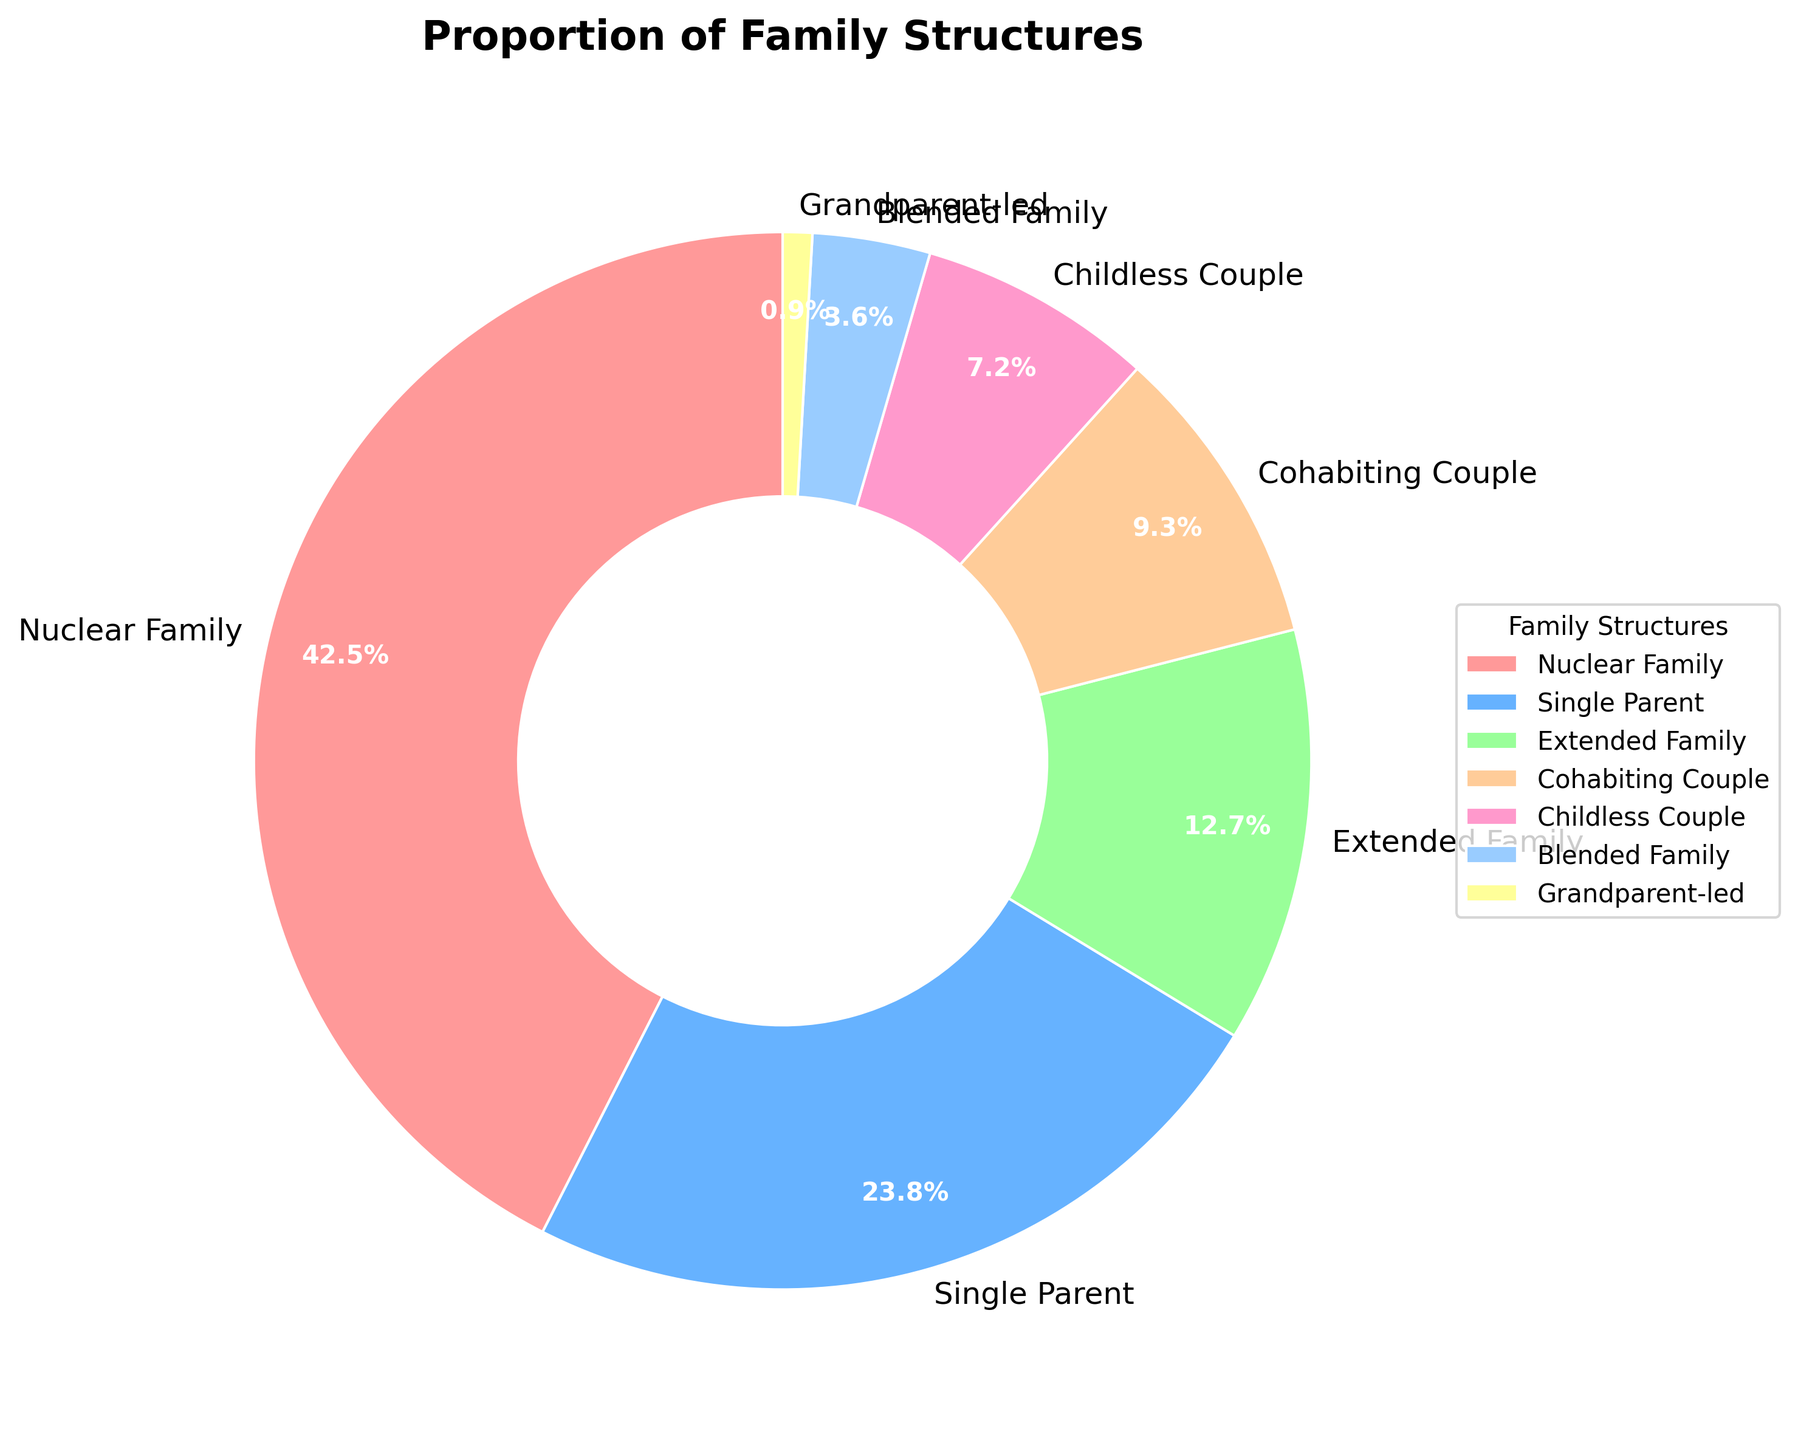What is the most common family structure in the population? To determine this, we look at the pie chart and identify the family structure with the largest slice. The provided data shows that "Nuclear Family" has the highest percentage at 42.5%.
Answer: Nuclear Family Which family structure has the smallest proportion in the population? By inspecting the pie chart, we identify the smallest slice, which corresponds to the "Grandparent-led" structure. The data confirms this with a percentage of 0.9%.
Answer: Grandparent-led What is the combined percentage of Single Parent and Extended Family structures? First, find the percentages of "Single Parent" (23.8%) and "Extended Family" (12.7%). Then, sum these values: 23.8 + 12.7 = 36.5%.
Answer: 36.5% Which family structure has nearly double the proportion of Childless Couple? The pie chart shows "Single Parent" at 23.8% and "Childless Couple" at 7.2%. Checking proportions, 23.8% is about double 7.2%.
Answer: Single Parent What is the difference in percentage points between Nuclear Family and Cohabiting Couple structures? Identify the percentages: "Nuclear Family" is 42.5% and "Cohabiting Couple" is 9.3%. Subtract these values: 42.5% - 9.3% = 33.2%.
Answer: 33.2% Which color represents the Blended Family structure? By examining the pie chart's color-coding and matching with the legend, the color representing "Blended Family" is identified. The correct color is a shade of blue.
Answer: Blue How much more common is the Nuclear Family structure compared to the Childless Couple structure? First, find their proportions: "Nuclear Family" (42.5%) and "Childless Couple" (7.2%). Subtract the smaller proportion from the larger one: 42.5% - 7.2% = 35.3%.
Answer: 35.3% If you sum up the proportions of Extended Family, Cohabiting Couple, and Grandparent-led structures, what percentage do you get? Identify each structure's percentage: "Extended Family" (12.7%), "Cohabiting Couple" (9.3%), and "Grandparent-led" (0.9%). Add them together: 12.7% + 9.3% + 0.9% = 22.9%.
Answer: 22.9% What is the visual position of the segment for Grandparent-led families in the pie chart? The segment for "Grandparent-led" families, being the smallest, would be visually represented by the smallest slice in the chart, and it is likely located near the bottom due to the start angle of the pie chart.
Answer: Near the bottom Which family structures have a percentage difference smaller than 5% when compared to Blended Family? The "Blended Family" is at 3.6%. Looking for structures within 5% range: 3.6% ± 5%, we find "Childless Couple" at 7.2% fitting this criterion, with an absolute difference of 3.6%.
Answer: Childless Couple 